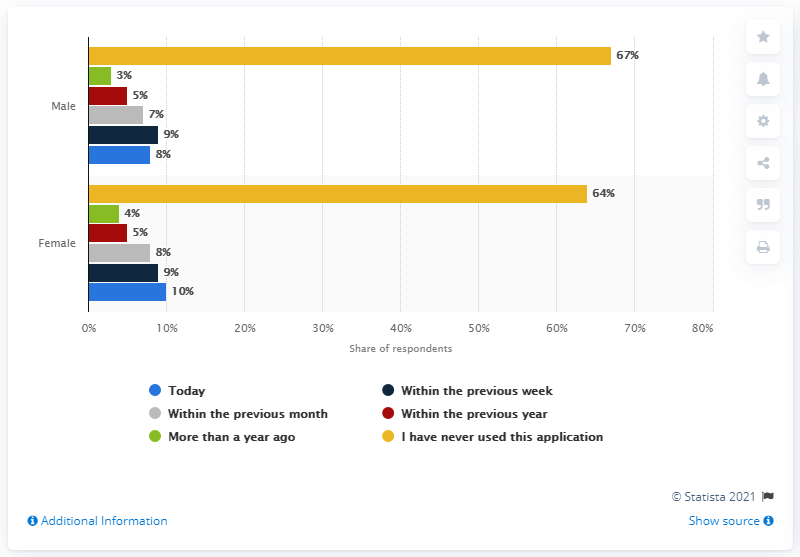Mention a couple of crucial points in this snapshot. The color bar with the highest share of users is yellow. The total share of users, both male and female, is currently 18%. 